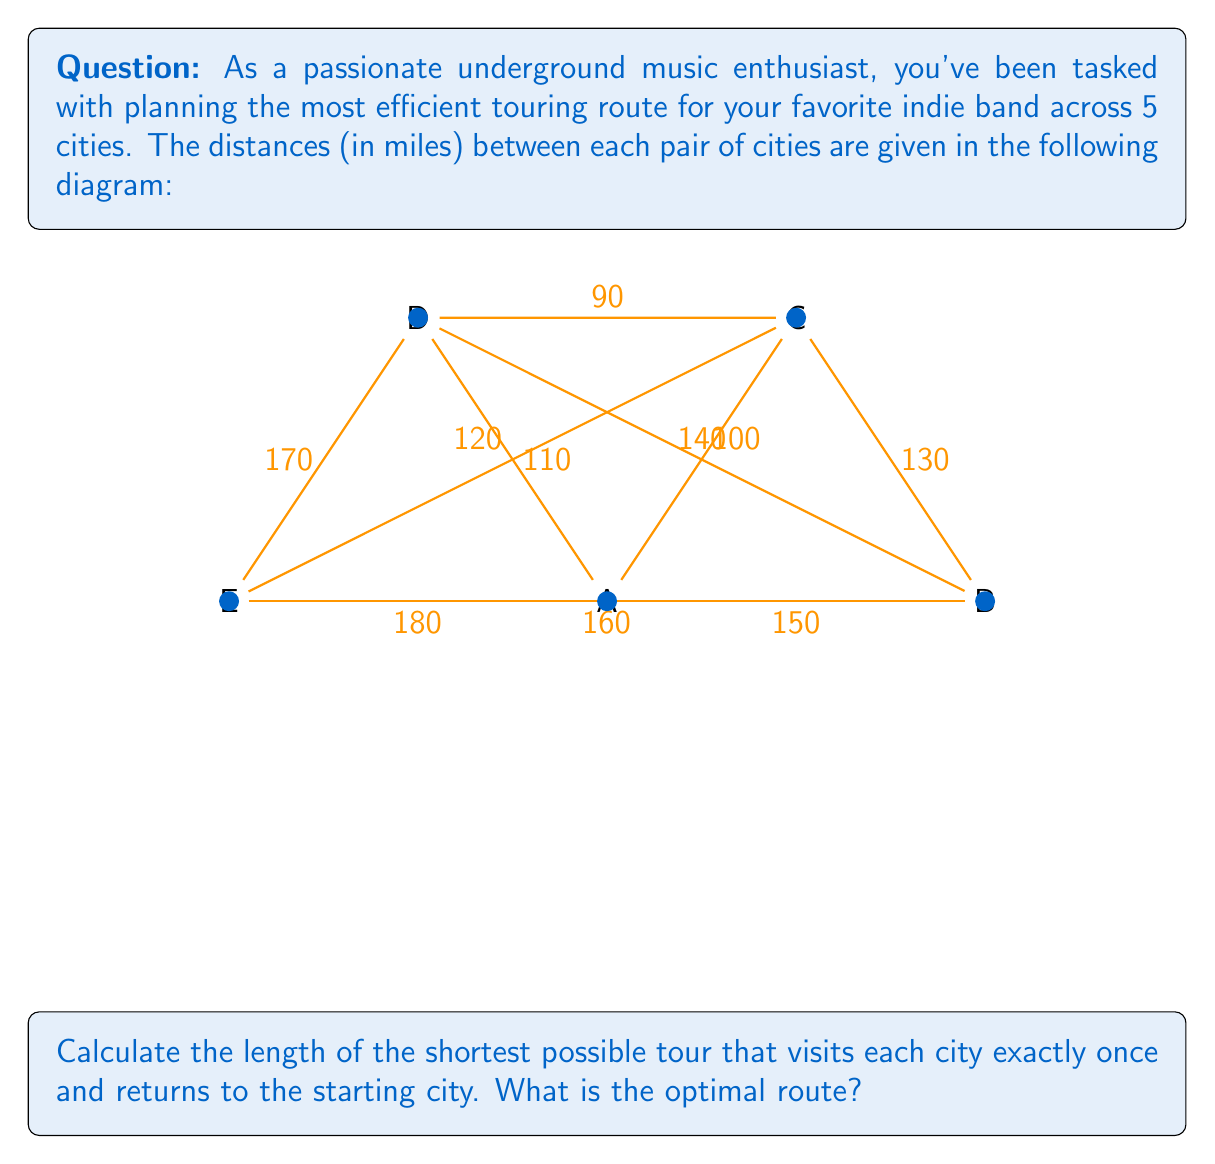Teach me how to tackle this problem. This problem is an instance of the Traveling Salesman Problem (TSP), which is NP-hard. For a small number of cities like this, we can use a brute-force approach to find the optimal solution.

Steps:
1) List all possible tours: There are (5-1)! = 24 possible tours, as we can fix the starting city.

2) Calculate the length of each tour. For example:
   A-B-C-D-E-A = 150 + 130 + 90 + 170 + 180 = 720 miles
   A-B-C-E-D-A = 150 + 130 + 110 + 170 + 120 = 680 miles
   ...

3) After calculating all 24 possibilities, we find the shortest tour:
   A-C-D-E-B-A = 100 + 90 + 170 + 160 + 150 = 670 miles

4) Verify that this is indeed the shortest by checking all other possibilities.

The optimal route can be represented mathematically as:
$$\text{argmin}_{\pi} \sum_{i=1}^{5} d(\pi(i), \pi(i+1))$$
where $\pi$ is a permutation of the cities, $d(x,y)$ is the distance between cities $x$ and $y$, and $\pi(6) = \pi(1)$ to complete the tour.
Answer: 670 miles; A-C-D-E-B-A 